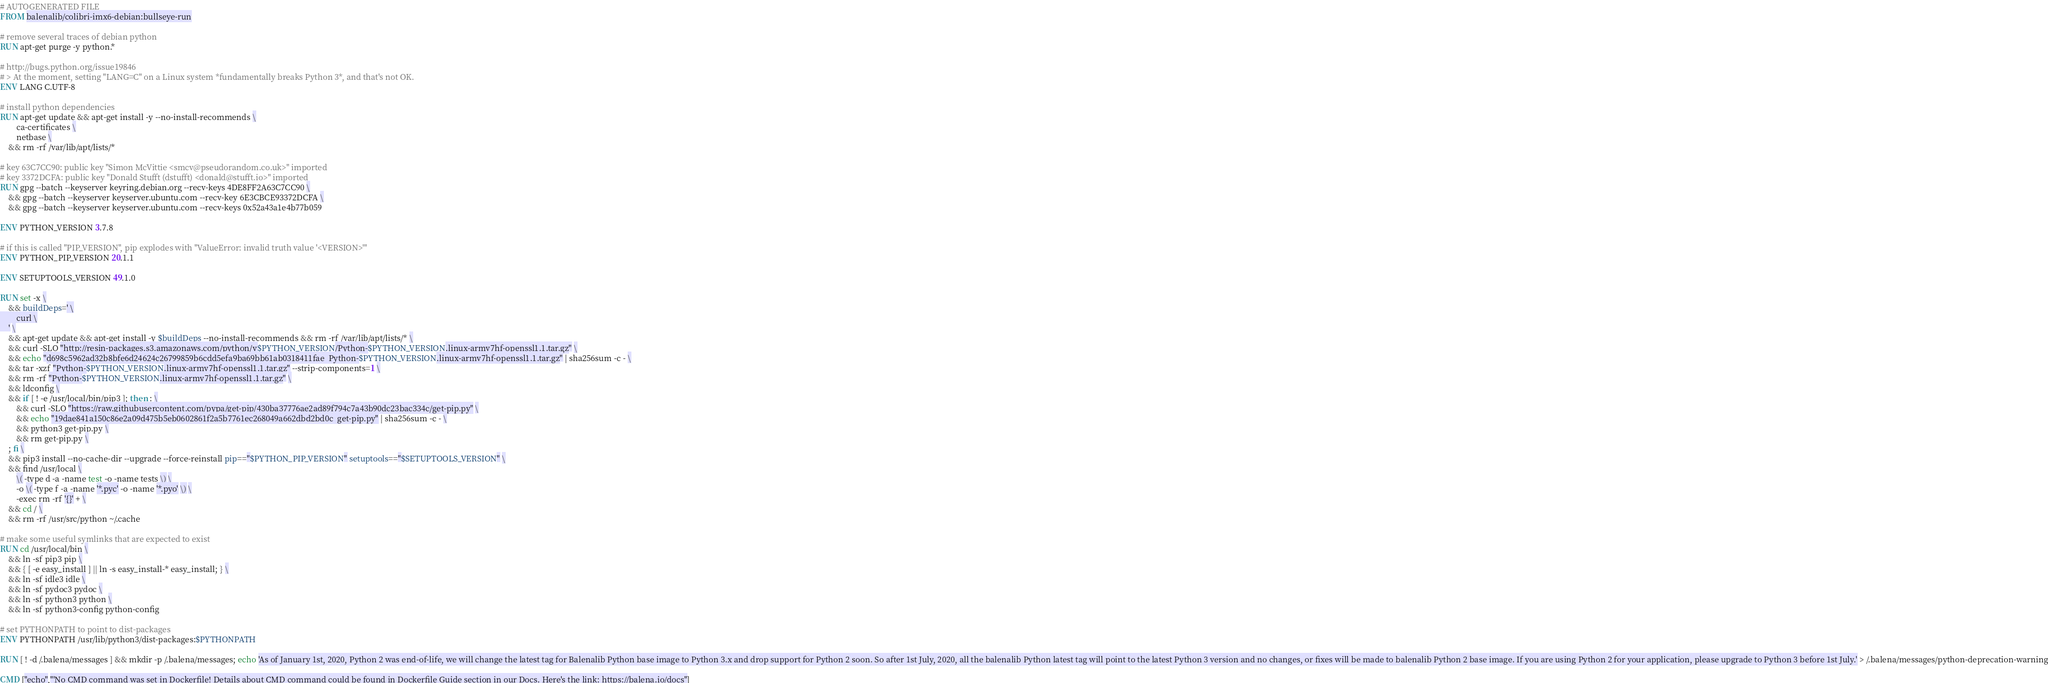Convert code to text. <code><loc_0><loc_0><loc_500><loc_500><_Dockerfile_># AUTOGENERATED FILE
FROM balenalib/colibri-imx6-debian:bullseye-run

# remove several traces of debian python
RUN apt-get purge -y python.*

# http://bugs.python.org/issue19846
# > At the moment, setting "LANG=C" on a Linux system *fundamentally breaks Python 3*, and that's not OK.
ENV LANG C.UTF-8

# install python dependencies
RUN apt-get update && apt-get install -y --no-install-recommends \
		ca-certificates \
		netbase \
	&& rm -rf /var/lib/apt/lists/*

# key 63C7CC90: public key "Simon McVittie <smcv@pseudorandom.co.uk>" imported
# key 3372DCFA: public key "Donald Stufft (dstufft) <donald@stufft.io>" imported
RUN gpg --batch --keyserver keyring.debian.org --recv-keys 4DE8FF2A63C7CC90 \
	&& gpg --batch --keyserver keyserver.ubuntu.com --recv-key 6E3CBCE93372DCFA \
	&& gpg --batch --keyserver keyserver.ubuntu.com --recv-keys 0x52a43a1e4b77b059

ENV PYTHON_VERSION 3.7.8

# if this is called "PIP_VERSION", pip explodes with "ValueError: invalid truth value '<VERSION>'"
ENV PYTHON_PIP_VERSION 20.1.1

ENV SETUPTOOLS_VERSION 49.1.0

RUN set -x \
	&& buildDeps=' \
		curl \
	' \
	&& apt-get update && apt-get install -y $buildDeps --no-install-recommends && rm -rf /var/lib/apt/lists/* \
	&& curl -SLO "http://resin-packages.s3.amazonaws.com/python/v$PYTHON_VERSION/Python-$PYTHON_VERSION.linux-armv7hf-openssl1.1.tar.gz" \
	&& echo "d698c5962ad32b8bfe6d24624c26799859b6cdd5efa9ba69bb61ab0318411fae  Python-$PYTHON_VERSION.linux-armv7hf-openssl1.1.tar.gz" | sha256sum -c - \
	&& tar -xzf "Python-$PYTHON_VERSION.linux-armv7hf-openssl1.1.tar.gz" --strip-components=1 \
	&& rm -rf "Python-$PYTHON_VERSION.linux-armv7hf-openssl1.1.tar.gz" \
	&& ldconfig \
	&& if [ ! -e /usr/local/bin/pip3 ]; then : \
		&& curl -SLO "https://raw.githubusercontent.com/pypa/get-pip/430ba37776ae2ad89f794c7a43b90dc23bac334c/get-pip.py" \
		&& echo "19dae841a150c86e2a09d475b5eb0602861f2a5b7761ec268049a662dbd2bd0c  get-pip.py" | sha256sum -c - \
		&& python3 get-pip.py \
		&& rm get-pip.py \
	; fi \
	&& pip3 install --no-cache-dir --upgrade --force-reinstall pip=="$PYTHON_PIP_VERSION" setuptools=="$SETUPTOOLS_VERSION" \
	&& find /usr/local \
		\( -type d -a -name test -o -name tests \) \
		-o \( -type f -a -name '*.pyc' -o -name '*.pyo' \) \
		-exec rm -rf '{}' + \
	&& cd / \
	&& rm -rf /usr/src/python ~/.cache

# make some useful symlinks that are expected to exist
RUN cd /usr/local/bin \
	&& ln -sf pip3 pip \
	&& { [ -e easy_install ] || ln -s easy_install-* easy_install; } \
	&& ln -sf idle3 idle \
	&& ln -sf pydoc3 pydoc \
	&& ln -sf python3 python \
	&& ln -sf python3-config python-config

# set PYTHONPATH to point to dist-packages
ENV PYTHONPATH /usr/lib/python3/dist-packages:$PYTHONPATH

RUN [ ! -d /.balena/messages ] && mkdir -p /.balena/messages; echo 'As of January 1st, 2020, Python 2 was end-of-life, we will change the latest tag for Balenalib Python base image to Python 3.x and drop support for Python 2 soon. So after 1st July, 2020, all the balenalib Python latest tag will point to the latest Python 3 version and no changes, or fixes will be made to balenalib Python 2 base image. If you are using Python 2 for your application, please upgrade to Python 3 before 1st July.' > /.balena/messages/python-deprecation-warning

CMD ["echo","'No CMD command was set in Dockerfile! Details about CMD command could be found in Dockerfile Guide section in our Docs. Here's the link: https://balena.io/docs"]
</code> 